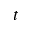Convert formula to latex. <formula><loc_0><loc_0><loc_500><loc_500>t</formula> 